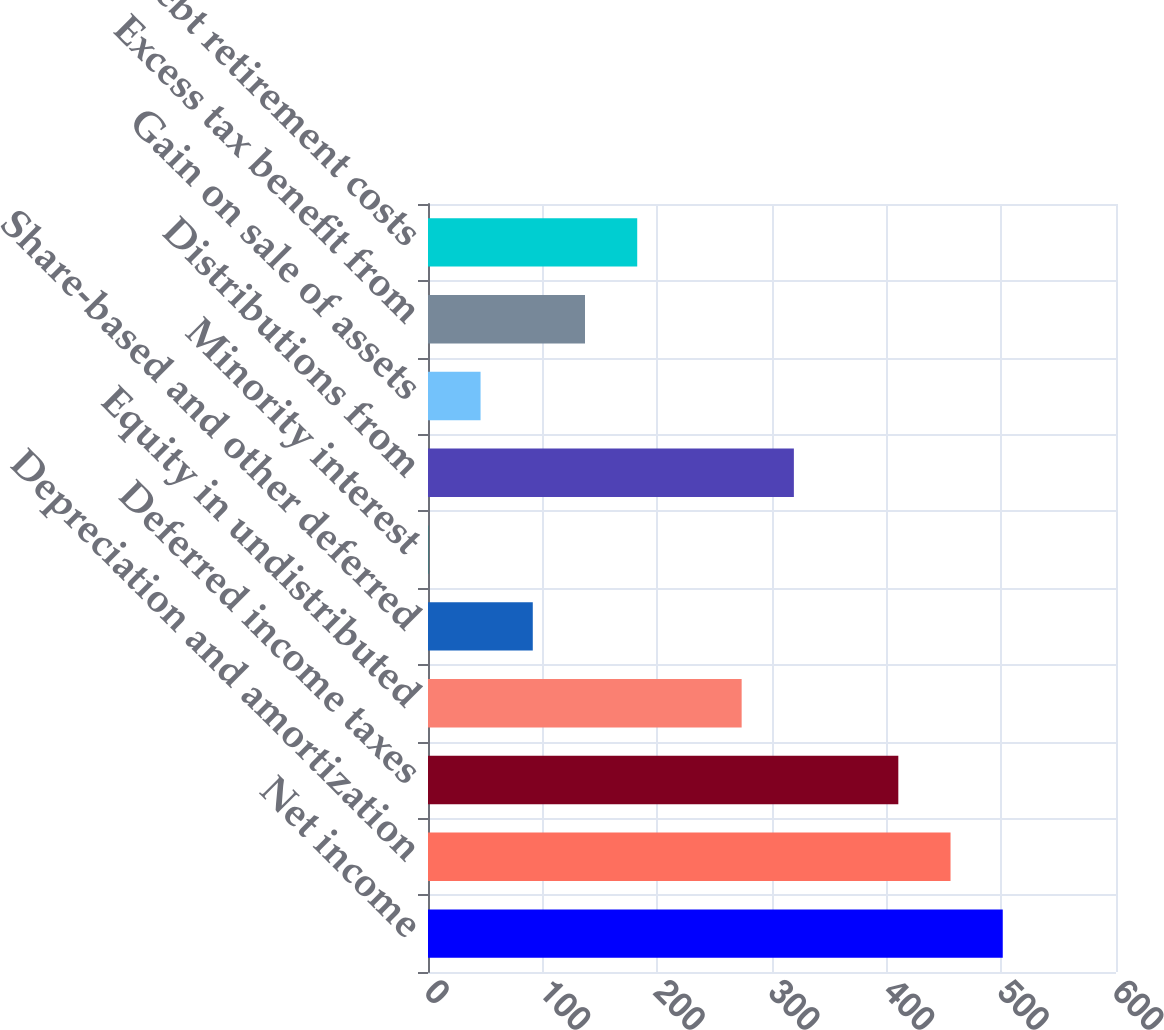Convert chart to OTSL. <chart><loc_0><loc_0><loc_500><loc_500><bar_chart><fcel>Net income<fcel>Depreciation and amortization<fcel>Deferred income taxes<fcel>Equity in undistributed<fcel>Share-based and other deferred<fcel>Minority interest<fcel>Distributions from<fcel>Gain on sale of assets<fcel>Excess tax benefit from<fcel>Debt retirement costs<nl><fcel>501.24<fcel>455.7<fcel>410.16<fcel>273.54<fcel>91.38<fcel>0.3<fcel>319.08<fcel>45.84<fcel>136.92<fcel>182.46<nl></chart> 